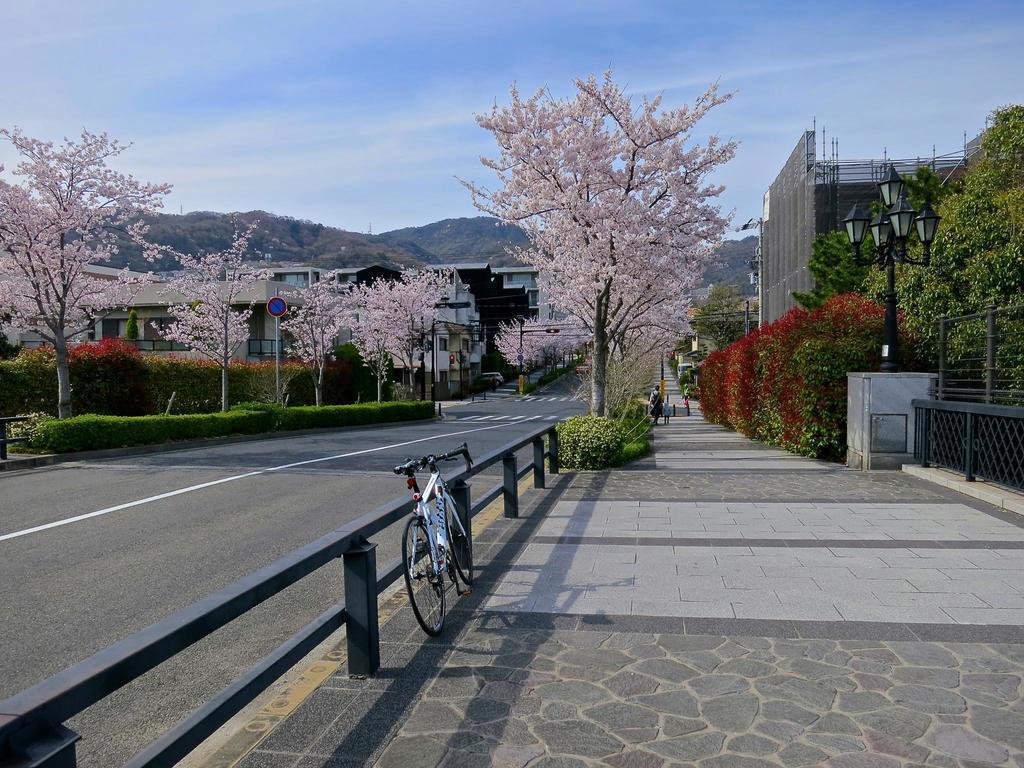How would you summarize this image in a sentence or two? In this picture there buildings and trees and street lights and there are boards on the poles. On the right side of the image there is a person walking on the footpath and there is a bicycle and there is a railing. At the back there are mountains. At the top there is sky and there are clouds. At the bottom there is a road. 